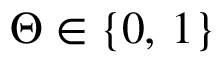<formula> <loc_0><loc_0><loc_500><loc_500>\Theta \in \{ 0 , \, 1 \}</formula> 